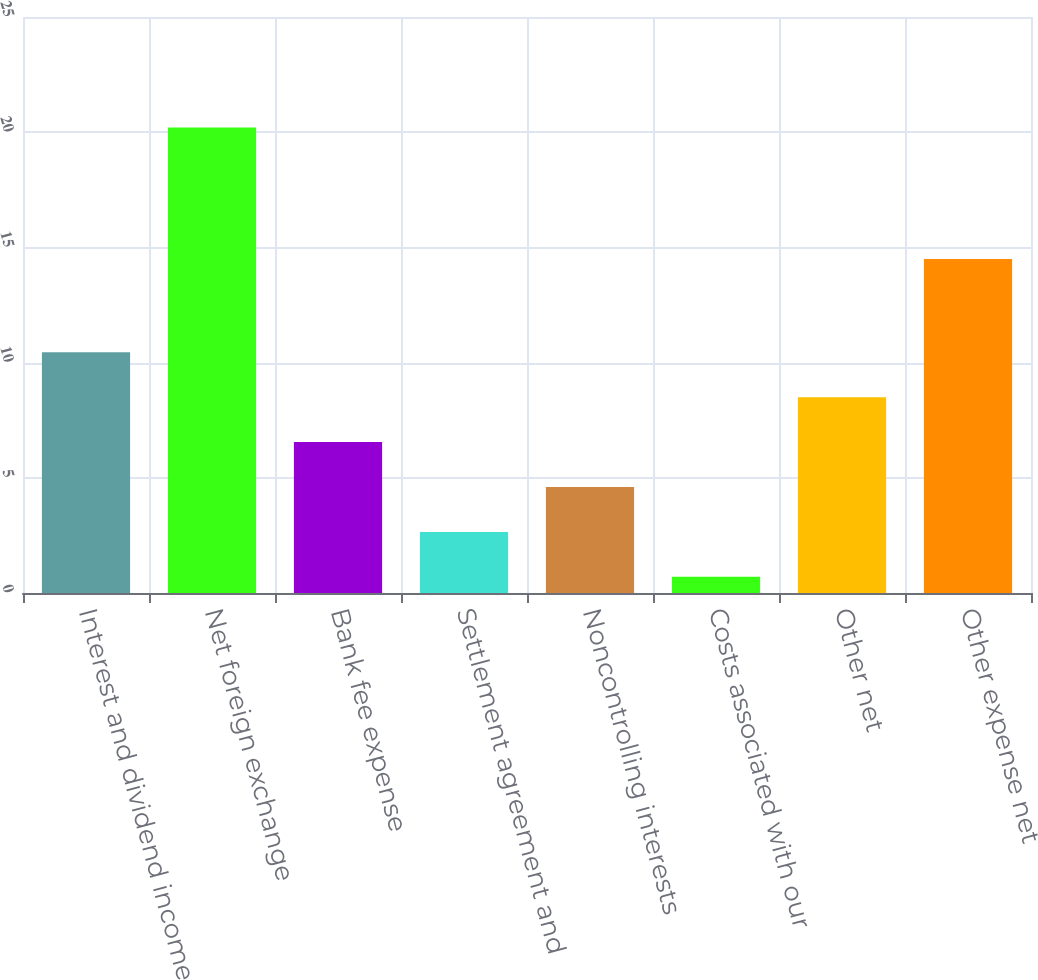<chart> <loc_0><loc_0><loc_500><loc_500><bar_chart><fcel>Interest and dividend income<fcel>Net foreign exchange<fcel>Bank fee expense<fcel>Settlement agreement and<fcel>Noncontrolling interests<fcel>Costs associated with our<fcel>Other net<fcel>Other expense net<nl><fcel>10.45<fcel>20.2<fcel>6.55<fcel>2.65<fcel>4.6<fcel>0.7<fcel>8.5<fcel>14.5<nl></chart> 